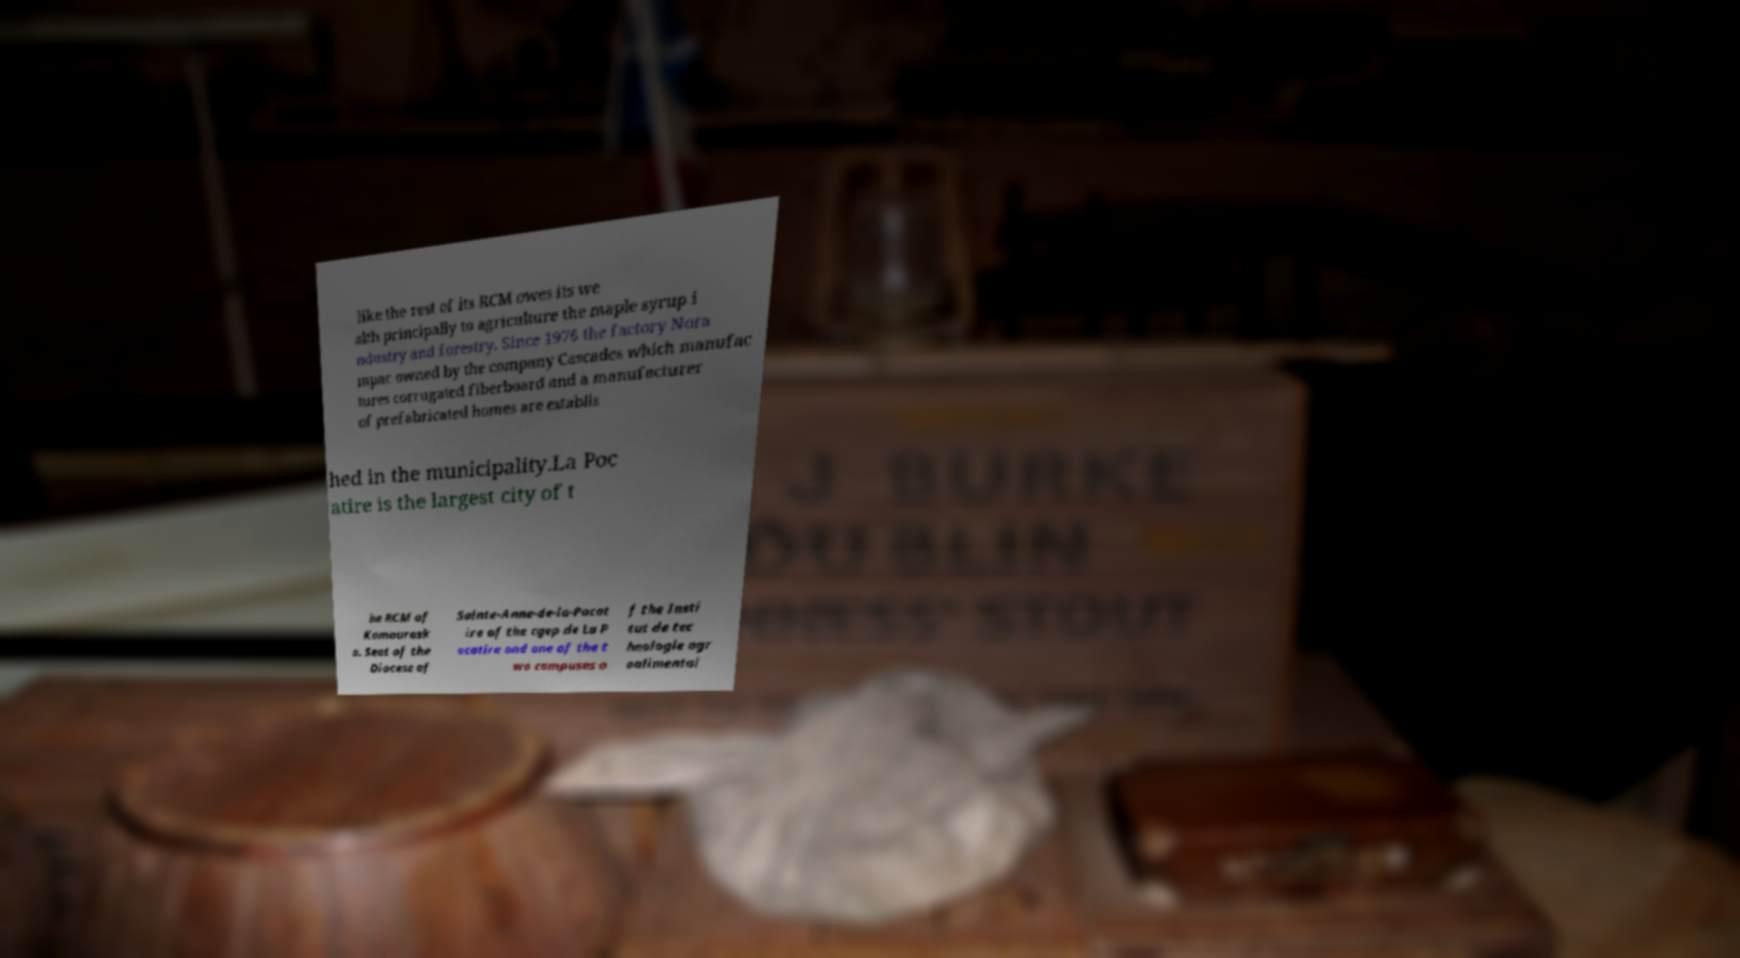I need the written content from this picture converted into text. Can you do that? like the rest of its RCM owes its we alth principally to agriculture the maple syrup i ndustry and forestry. Since 1976 the factory Nora mpac owned by the company Cascades which manufac tures corrugated fiberboard and a manufacturer of prefabricated homes are establis hed in the municipality.La Poc atire is the largest city of t he RCM of Kamourask a. Seat of the Diocese of Sainte-Anne-de-la-Pocat ire of the cgep de La P ocatire and one of the t wo campuses o f the Insti tut de tec hnologie agr oalimentai 